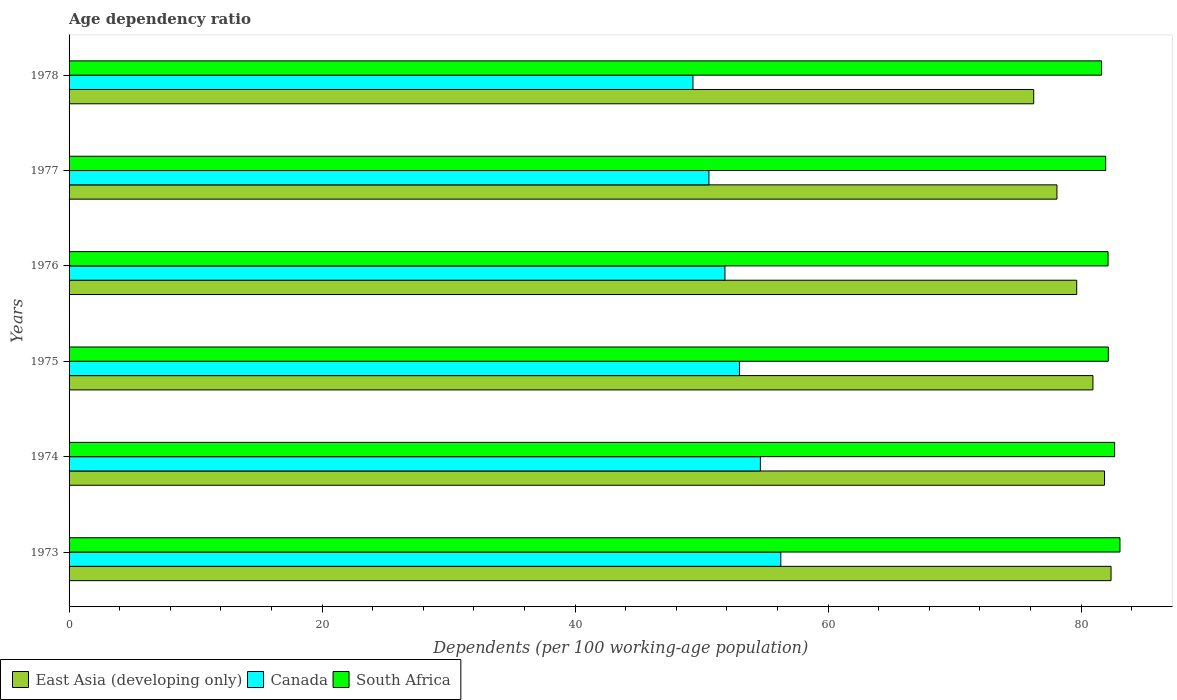How many different coloured bars are there?
Give a very brief answer. 3. Are the number of bars per tick equal to the number of legend labels?
Provide a short and direct response. Yes. Are the number of bars on each tick of the Y-axis equal?
Your answer should be compact. Yes. How many bars are there on the 2nd tick from the bottom?
Offer a terse response. 3. What is the label of the 2nd group of bars from the top?
Keep it short and to the point. 1977. In how many cases, is the number of bars for a given year not equal to the number of legend labels?
Your answer should be very brief. 0. What is the age dependency ratio in in East Asia (developing only) in 1974?
Your answer should be compact. 81.86. Across all years, what is the maximum age dependency ratio in in South Africa?
Provide a succinct answer. 83.08. Across all years, what is the minimum age dependency ratio in in East Asia (developing only)?
Ensure brevity in your answer.  76.26. In which year was the age dependency ratio in in South Africa maximum?
Your answer should be very brief. 1973. In which year was the age dependency ratio in in East Asia (developing only) minimum?
Your answer should be compact. 1978. What is the total age dependency ratio in in South Africa in the graph?
Ensure brevity in your answer.  493.59. What is the difference between the age dependency ratio in in South Africa in 1974 and that in 1975?
Your answer should be compact. 0.5. What is the difference between the age dependency ratio in in Canada in 1977 and the age dependency ratio in in East Asia (developing only) in 1975?
Your answer should be very brief. -30.36. What is the average age dependency ratio in in Canada per year?
Offer a terse response. 52.61. In the year 1978, what is the difference between the age dependency ratio in in South Africa and age dependency ratio in in East Asia (developing only)?
Give a very brief answer. 5.36. In how many years, is the age dependency ratio in in East Asia (developing only) greater than 12 %?
Provide a succinct answer. 6. What is the ratio of the age dependency ratio in in East Asia (developing only) in 1973 to that in 1978?
Provide a succinct answer. 1.08. Is the difference between the age dependency ratio in in South Africa in 1973 and 1974 greater than the difference between the age dependency ratio in in East Asia (developing only) in 1973 and 1974?
Keep it short and to the point. No. What is the difference between the highest and the second highest age dependency ratio in in Canada?
Keep it short and to the point. 1.62. What is the difference between the highest and the lowest age dependency ratio in in South Africa?
Make the answer very short. 1.46. What does the 3rd bar from the bottom in 1976 represents?
Provide a short and direct response. South Africa. How many years are there in the graph?
Your answer should be very brief. 6. How are the legend labels stacked?
Provide a succinct answer. Horizontal. What is the title of the graph?
Provide a succinct answer. Age dependency ratio. What is the label or title of the X-axis?
Make the answer very short. Dependents (per 100 working-age population). What is the label or title of the Y-axis?
Offer a terse response. Years. What is the Dependents (per 100 working-age population) of East Asia (developing only) in 1973?
Your response must be concise. 82.37. What is the Dependents (per 100 working-age population) in Canada in 1973?
Your response must be concise. 56.27. What is the Dependents (per 100 working-age population) of South Africa in 1973?
Your answer should be compact. 83.08. What is the Dependents (per 100 working-age population) in East Asia (developing only) in 1974?
Your answer should be compact. 81.86. What is the Dependents (per 100 working-age population) in Canada in 1974?
Ensure brevity in your answer.  54.65. What is the Dependents (per 100 working-age population) of South Africa in 1974?
Offer a terse response. 82.66. What is the Dependents (per 100 working-age population) in East Asia (developing only) in 1975?
Your answer should be very brief. 80.94. What is the Dependents (per 100 working-age population) of Canada in 1975?
Make the answer very short. 53. What is the Dependents (per 100 working-age population) in South Africa in 1975?
Make the answer very short. 82.15. What is the Dependents (per 100 working-age population) of East Asia (developing only) in 1976?
Make the answer very short. 79.66. What is the Dependents (per 100 working-age population) in Canada in 1976?
Make the answer very short. 51.85. What is the Dependents (per 100 working-age population) of South Africa in 1976?
Give a very brief answer. 82.14. What is the Dependents (per 100 working-age population) in East Asia (developing only) in 1977?
Your response must be concise. 78.1. What is the Dependents (per 100 working-age population) of Canada in 1977?
Your answer should be very brief. 50.58. What is the Dependents (per 100 working-age population) of South Africa in 1977?
Make the answer very short. 81.95. What is the Dependents (per 100 working-age population) of East Asia (developing only) in 1978?
Your answer should be very brief. 76.26. What is the Dependents (per 100 working-age population) of Canada in 1978?
Your answer should be compact. 49.32. What is the Dependents (per 100 working-age population) of South Africa in 1978?
Offer a terse response. 81.62. Across all years, what is the maximum Dependents (per 100 working-age population) in East Asia (developing only)?
Your response must be concise. 82.37. Across all years, what is the maximum Dependents (per 100 working-age population) of Canada?
Provide a short and direct response. 56.27. Across all years, what is the maximum Dependents (per 100 working-age population) of South Africa?
Make the answer very short. 83.08. Across all years, what is the minimum Dependents (per 100 working-age population) in East Asia (developing only)?
Ensure brevity in your answer.  76.26. Across all years, what is the minimum Dependents (per 100 working-age population) in Canada?
Provide a succinct answer. 49.32. Across all years, what is the minimum Dependents (per 100 working-age population) of South Africa?
Provide a short and direct response. 81.62. What is the total Dependents (per 100 working-age population) in East Asia (developing only) in the graph?
Give a very brief answer. 479.18. What is the total Dependents (per 100 working-age population) of Canada in the graph?
Make the answer very short. 315.67. What is the total Dependents (per 100 working-age population) in South Africa in the graph?
Your answer should be very brief. 493.59. What is the difference between the Dependents (per 100 working-age population) of East Asia (developing only) in 1973 and that in 1974?
Keep it short and to the point. 0.52. What is the difference between the Dependents (per 100 working-age population) in Canada in 1973 and that in 1974?
Your answer should be compact. 1.62. What is the difference between the Dependents (per 100 working-age population) of South Africa in 1973 and that in 1974?
Offer a very short reply. 0.42. What is the difference between the Dependents (per 100 working-age population) of East Asia (developing only) in 1973 and that in 1975?
Provide a short and direct response. 1.43. What is the difference between the Dependents (per 100 working-age population) of Canada in 1973 and that in 1975?
Make the answer very short. 3.27. What is the difference between the Dependents (per 100 working-age population) in South Africa in 1973 and that in 1975?
Provide a succinct answer. 0.92. What is the difference between the Dependents (per 100 working-age population) of East Asia (developing only) in 1973 and that in 1976?
Make the answer very short. 2.71. What is the difference between the Dependents (per 100 working-age population) in Canada in 1973 and that in 1976?
Ensure brevity in your answer.  4.41. What is the difference between the Dependents (per 100 working-age population) in South Africa in 1973 and that in 1976?
Give a very brief answer. 0.94. What is the difference between the Dependents (per 100 working-age population) in East Asia (developing only) in 1973 and that in 1977?
Offer a very short reply. 4.28. What is the difference between the Dependents (per 100 working-age population) in Canada in 1973 and that in 1977?
Offer a terse response. 5.68. What is the difference between the Dependents (per 100 working-age population) in South Africa in 1973 and that in 1977?
Your response must be concise. 1.13. What is the difference between the Dependents (per 100 working-age population) of East Asia (developing only) in 1973 and that in 1978?
Your answer should be compact. 6.11. What is the difference between the Dependents (per 100 working-age population) in Canada in 1973 and that in 1978?
Your response must be concise. 6.94. What is the difference between the Dependents (per 100 working-age population) in South Africa in 1973 and that in 1978?
Your answer should be very brief. 1.46. What is the difference between the Dependents (per 100 working-age population) of East Asia (developing only) in 1974 and that in 1975?
Offer a very short reply. 0.92. What is the difference between the Dependents (per 100 working-age population) in Canada in 1974 and that in 1975?
Offer a terse response. 1.65. What is the difference between the Dependents (per 100 working-age population) in South Africa in 1974 and that in 1975?
Offer a very short reply. 0.5. What is the difference between the Dependents (per 100 working-age population) in East Asia (developing only) in 1974 and that in 1976?
Give a very brief answer. 2.2. What is the difference between the Dependents (per 100 working-age population) of Canada in 1974 and that in 1976?
Ensure brevity in your answer.  2.8. What is the difference between the Dependents (per 100 working-age population) in South Africa in 1974 and that in 1976?
Offer a very short reply. 0.52. What is the difference between the Dependents (per 100 working-age population) of East Asia (developing only) in 1974 and that in 1977?
Keep it short and to the point. 3.76. What is the difference between the Dependents (per 100 working-age population) in Canada in 1974 and that in 1977?
Your response must be concise. 4.07. What is the difference between the Dependents (per 100 working-age population) of South Africa in 1974 and that in 1977?
Your answer should be very brief. 0.71. What is the difference between the Dependents (per 100 working-age population) of East Asia (developing only) in 1974 and that in 1978?
Provide a short and direct response. 5.6. What is the difference between the Dependents (per 100 working-age population) of Canada in 1974 and that in 1978?
Provide a short and direct response. 5.33. What is the difference between the Dependents (per 100 working-age population) of South Africa in 1974 and that in 1978?
Offer a terse response. 1.03. What is the difference between the Dependents (per 100 working-age population) in East Asia (developing only) in 1975 and that in 1976?
Give a very brief answer. 1.28. What is the difference between the Dependents (per 100 working-age population) of Canada in 1975 and that in 1976?
Keep it short and to the point. 1.15. What is the difference between the Dependents (per 100 working-age population) in South Africa in 1975 and that in 1976?
Offer a terse response. 0.02. What is the difference between the Dependents (per 100 working-age population) in East Asia (developing only) in 1975 and that in 1977?
Give a very brief answer. 2.84. What is the difference between the Dependents (per 100 working-age population) of Canada in 1975 and that in 1977?
Ensure brevity in your answer.  2.41. What is the difference between the Dependents (per 100 working-age population) in South Africa in 1975 and that in 1977?
Offer a very short reply. 0.21. What is the difference between the Dependents (per 100 working-age population) of East Asia (developing only) in 1975 and that in 1978?
Your answer should be very brief. 4.68. What is the difference between the Dependents (per 100 working-age population) of Canada in 1975 and that in 1978?
Your answer should be compact. 3.67. What is the difference between the Dependents (per 100 working-age population) in South Africa in 1975 and that in 1978?
Provide a short and direct response. 0.53. What is the difference between the Dependents (per 100 working-age population) of East Asia (developing only) in 1976 and that in 1977?
Make the answer very short. 1.56. What is the difference between the Dependents (per 100 working-age population) of Canada in 1976 and that in 1977?
Provide a succinct answer. 1.27. What is the difference between the Dependents (per 100 working-age population) in South Africa in 1976 and that in 1977?
Ensure brevity in your answer.  0.19. What is the difference between the Dependents (per 100 working-age population) of East Asia (developing only) in 1976 and that in 1978?
Your answer should be very brief. 3.4. What is the difference between the Dependents (per 100 working-age population) of Canada in 1976 and that in 1978?
Give a very brief answer. 2.53. What is the difference between the Dependents (per 100 working-age population) of South Africa in 1976 and that in 1978?
Provide a succinct answer. 0.52. What is the difference between the Dependents (per 100 working-age population) in East Asia (developing only) in 1977 and that in 1978?
Provide a short and direct response. 1.84. What is the difference between the Dependents (per 100 working-age population) in Canada in 1977 and that in 1978?
Make the answer very short. 1.26. What is the difference between the Dependents (per 100 working-age population) in South Africa in 1977 and that in 1978?
Provide a short and direct response. 0.33. What is the difference between the Dependents (per 100 working-age population) of East Asia (developing only) in 1973 and the Dependents (per 100 working-age population) of Canada in 1974?
Keep it short and to the point. 27.72. What is the difference between the Dependents (per 100 working-age population) in East Asia (developing only) in 1973 and the Dependents (per 100 working-age population) in South Africa in 1974?
Keep it short and to the point. -0.28. What is the difference between the Dependents (per 100 working-age population) of Canada in 1973 and the Dependents (per 100 working-age population) of South Africa in 1974?
Your answer should be compact. -26.39. What is the difference between the Dependents (per 100 working-age population) of East Asia (developing only) in 1973 and the Dependents (per 100 working-age population) of Canada in 1975?
Your answer should be compact. 29.38. What is the difference between the Dependents (per 100 working-age population) in East Asia (developing only) in 1973 and the Dependents (per 100 working-age population) in South Africa in 1975?
Offer a very short reply. 0.22. What is the difference between the Dependents (per 100 working-age population) in Canada in 1973 and the Dependents (per 100 working-age population) in South Africa in 1975?
Your answer should be very brief. -25.89. What is the difference between the Dependents (per 100 working-age population) of East Asia (developing only) in 1973 and the Dependents (per 100 working-age population) of Canada in 1976?
Offer a very short reply. 30.52. What is the difference between the Dependents (per 100 working-age population) of East Asia (developing only) in 1973 and the Dependents (per 100 working-age population) of South Africa in 1976?
Provide a succinct answer. 0.23. What is the difference between the Dependents (per 100 working-age population) of Canada in 1973 and the Dependents (per 100 working-age population) of South Africa in 1976?
Make the answer very short. -25.87. What is the difference between the Dependents (per 100 working-age population) in East Asia (developing only) in 1973 and the Dependents (per 100 working-age population) in Canada in 1977?
Your answer should be very brief. 31.79. What is the difference between the Dependents (per 100 working-age population) of East Asia (developing only) in 1973 and the Dependents (per 100 working-age population) of South Africa in 1977?
Your response must be concise. 0.42. What is the difference between the Dependents (per 100 working-age population) in Canada in 1973 and the Dependents (per 100 working-age population) in South Africa in 1977?
Keep it short and to the point. -25.68. What is the difference between the Dependents (per 100 working-age population) in East Asia (developing only) in 1973 and the Dependents (per 100 working-age population) in Canada in 1978?
Your response must be concise. 33.05. What is the difference between the Dependents (per 100 working-age population) of East Asia (developing only) in 1973 and the Dependents (per 100 working-age population) of South Africa in 1978?
Your answer should be compact. 0.75. What is the difference between the Dependents (per 100 working-age population) of Canada in 1973 and the Dependents (per 100 working-age population) of South Africa in 1978?
Offer a very short reply. -25.36. What is the difference between the Dependents (per 100 working-age population) in East Asia (developing only) in 1974 and the Dependents (per 100 working-age population) in Canada in 1975?
Ensure brevity in your answer.  28.86. What is the difference between the Dependents (per 100 working-age population) of East Asia (developing only) in 1974 and the Dependents (per 100 working-age population) of South Africa in 1975?
Offer a terse response. -0.3. What is the difference between the Dependents (per 100 working-age population) in Canada in 1974 and the Dependents (per 100 working-age population) in South Africa in 1975?
Give a very brief answer. -27.5. What is the difference between the Dependents (per 100 working-age population) in East Asia (developing only) in 1974 and the Dependents (per 100 working-age population) in Canada in 1976?
Ensure brevity in your answer.  30.01. What is the difference between the Dependents (per 100 working-age population) of East Asia (developing only) in 1974 and the Dependents (per 100 working-age population) of South Africa in 1976?
Your answer should be compact. -0.28. What is the difference between the Dependents (per 100 working-age population) of Canada in 1974 and the Dependents (per 100 working-age population) of South Africa in 1976?
Your response must be concise. -27.49. What is the difference between the Dependents (per 100 working-age population) in East Asia (developing only) in 1974 and the Dependents (per 100 working-age population) in Canada in 1977?
Keep it short and to the point. 31.27. What is the difference between the Dependents (per 100 working-age population) in East Asia (developing only) in 1974 and the Dependents (per 100 working-age population) in South Africa in 1977?
Offer a terse response. -0.09. What is the difference between the Dependents (per 100 working-age population) in Canada in 1974 and the Dependents (per 100 working-age population) in South Africa in 1977?
Offer a terse response. -27.3. What is the difference between the Dependents (per 100 working-age population) in East Asia (developing only) in 1974 and the Dependents (per 100 working-age population) in Canada in 1978?
Keep it short and to the point. 32.53. What is the difference between the Dependents (per 100 working-age population) of East Asia (developing only) in 1974 and the Dependents (per 100 working-age population) of South Africa in 1978?
Provide a short and direct response. 0.24. What is the difference between the Dependents (per 100 working-age population) in Canada in 1974 and the Dependents (per 100 working-age population) in South Africa in 1978?
Provide a succinct answer. -26.97. What is the difference between the Dependents (per 100 working-age population) in East Asia (developing only) in 1975 and the Dependents (per 100 working-age population) in Canada in 1976?
Ensure brevity in your answer.  29.09. What is the difference between the Dependents (per 100 working-age population) of East Asia (developing only) in 1975 and the Dependents (per 100 working-age population) of South Africa in 1976?
Provide a succinct answer. -1.2. What is the difference between the Dependents (per 100 working-age population) of Canada in 1975 and the Dependents (per 100 working-age population) of South Africa in 1976?
Your response must be concise. -29.14. What is the difference between the Dependents (per 100 working-age population) of East Asia (developing only) in 1975 and the Dependents (per 100 working-age population) of Canada in 1977?
Offer a very short reply. 30.36. What is the difference between the Dependents (per 100 working-age population) of East Asia (developing only) in 1975 and the Dependents (per 100 working-age population) of South Africa in 1977?
Keep it short and to the point. -1.01. What is the difference between the Dependents (per 100 working-age population) of Canada in 1975 and the Dependents (per 100 working-age population) of South Africa in 1977?
Give a very brief answer. -28.95. What is the difference between the Dependents (per 100 working-age population) of East Asia (developing only) in 1975 and the Dependents (per 100 working-age population) of Canada in 1978?
Ensure brevity in your answer.  31.62. What is the difference between the Dependents (per 100 working-age population) of East Asia (developing only) in 1975 and the Dependents (per 100 working-age population) of South Africa in 1978?
Your response must be concise. -0.68. What is the difference between the Dependents (per 100 working-age population) in Canada in 1975 and the Dependents (per 100 working-age population) in South Africa in 1978?
Keep it short and to the point. -28.62. What is the difference between the Dependents (per 100 working-age population) of East Asia (developing only) in 1976 and the Dependents (per 100 working-age population) of Canada in 1977?
Your answer should be very brief. 29.08. What is the difference between the Dependents (per 100 working-age population) in East Asia (developing only) in 1976 and the Dependents (per 100 working-age population) in South Africa in 1977?
Your response must be concise. -2.29. What is the difference between the Dependents (per 100 working-age population) in Canada in 1976 and the Dependents (per 100 working-age population) in South Africa in 1977?
Ensure brevity in your answer.  -30.1. What is the difference between the Dependents (per 100 working-age population) of East Asia (developing only) in 1976 and the Dependents (per 100 working-age population) of Canada in 1978?
Provide a short and direct response. 30.34. What is the difference between the Dependents (per 100 working-age population) in East Asia (developing only) in 1976 and the Dependents (per 100 working-age population) in South Africa in 1978?
Provide a succinct answer. -1.96. What is the difference between the Dependents (per 100 working-age population) of Canada in 1976 and the Dependents (per 100 working-age population) of South Africa in 1978?
Your response must be concise. -29.77. What is the difference between the Dependents (per 100 working-age population) in East Asia (developing only) in 1977 and the Dependents (per 100 working-age population) in Canada in 1978?
Offer a very short reply. 28.77. What is the difference between the Dependents (per 100 working-age population) in East Asia (developing only) in 1977 and the Dependents (per 100 working-age population) in South Africa in 1978?
Make the answer very short. -3.52. What is the difference between the Dependents (per 100 working-age population) of Canada in 1977 and the Dependents (per 100 working-age population) of South Africa in 1978?
Your answer should be compact. -31.04. What is the average Dependents (per 100 working-age population) of East Asia (developing only) per year?
Provide a succinct answer. 79.86. What is the average Dependents (per 100 working-age population) in Canada per year?
Provide a succinct answer. 52.61. What is the average Dependents (per 100 working-age population) in South Africa per year?
Your answer should be very brief. 82.27. In the year 1973, what is the difference between the Dependents (per 100 working-age population) of East Asia (developing only) and Dependents (per 100 working-age population) of Canada?
Your answer should be very brief. 26.11. In the year 1973, what is the difference between the Dependents (per 100 working-age population) in East Asia (developing only) and Dependents (per 100 working-age population) in South Africa?
Provide a short and direct response. -0.7. In the year 1973, what is the difference between the Dependents (per 100 working-age population) in Canada and Dependents (per 100 working-age population) in South Africa?
Ensure brevity in your answer.  -26.81. In the year 1974, what is the difference between the Dependents (per 100 working-age population) in East Asia (developing only) and Dependents (per 100 working-age population) in Canada?
Your response must be concise. 27.21. In the year 1974, what is the difference between the Dependents (per 100 working-age population) in East Asia (developing only) and Dependents (per 100 working-age population) in South Africa?
Give a very brief answer. -0.8. In the year 1974, what is the difference between the Dependents (per 100 working-age population) of Canada and Dependents (per 100 working-age population) of South Africa?
Your answer should be compact. -28.01. In the year 1975, what is the difference between the Dependents (per 100 working-age population) in East Asia (developing only) and Dependents (per 100 working-age population) in Canada?
Keep it short and to the point. 27.94. In the year 1975, what is the difference between the Dependents (per 100 working-age population) of East Asia (developing only) and Dependents (per 100 working-age population) of South Africa?
Give a very brief answer. -1.21. In the year 1975, what is the difference between the Dependents (per 100 working-age population) of Canada and Dependents (per 100 working-age population) of South Africa?
Give a very brief answer. -29.16. In the year 1976, what is the difference between the Dependents (per 100 working-age population) of East Asia (developing only) and Dependents (per 100 working-age population) of Canada?
Ensure brevity in your answer.  27.81. In the year 1976, what is the difference between the Dependents (per 100 working-age population) of East Asia (developing only) and Dependents (per 100 working-age population) of South Africa?
Your answer should be compact. -2.48. In the year 1976, what is the difference between the Dependents (per 100 working-age population) in Canada and Dependents (per 100 working-age population) in South Africa?
Your answer should be compact. -30.29. In the year 1977, what is the difference between the Dependents (per 100 working-age population) in East Asia (developing only) and Dependents (per 100 working-age population) in Canada?
Ensure brevity in your answer.  27.51. In the year 1977, what is the difference between the Dependents (per 100 working-age population) of East Asia (developing only) and Dependents (per 100 working-age population) of South Africa?
Your response must be concise. -3.85. In the year 1977, what is the difference between the Dependents (per 100 working-age population) in Canada and Dependents (per 100 working-age population) in South Africa?
Your answer should be compact. -31.36. In the year 1978, what is the difference between the Dependents (per 100 working-age population) in East Asia (developing only) and Dependents (per 100 working-age population) in Canada?
Ensure brevity in your answer.  26.94. In the year 1978, what is the difference between the Dependents (per 100 working-age population) of East Asia (developing only) and Dependents (per 100 working-age population) of South Africa?
Provide a short and direct response. -5.36. In the year 1978, what is the difference between the Dependents (per 100 working-age population) in Canada and Dependents (per 100 working-age population) in South Africa?
Keep it short and to the point. -32.3. What is the ratio of the Dependents (per 100 working-age population) in East Asia (developing only) in 1973 to that in 1974?
Provide a short and direct response. 1.01. What is the ratio of the Dependents (per 100 working-age population) of Canada in 1973 to that in 1974?
Offer a very short reply. 1.03. What is the ratio of the Dependents (per 100 working-age population) of South Africa in 1973 to that in 1974?
Your answer should be very brief. 1.01. What is the ratio of the Dependents (per 100 working-age population) in East Asia (developing only) in 1973 to that in 1975?
Provide a succinct answer. 1.02. What is the ratio of the Dependents (per 100 working-age population) of Canada in 1973 to that in 1975?
Provide a short and direct response. 1.06. What is the ratio of the Dependents (per 100 working-age population) of South Africa in 1973 to that in 1975?
Your answer should be compact. 1.01. What is the ratio of the Dependents (per 100 working-age population) of East Asia (developing only) in 1973 to that in 1976?
Your response must be concise. 1.03. What is the ratio of the Dependents (per 100 working-age population) in Canada in 1973 to that in 1976?
Provide a short and direct response. 1.09. What is the ratio of the Dependents (per 100 working-age population) in South Africa in 1973 to that in 1976?
Ensure brevity in your answer.  1.01. What is the ratio of the Dependents (per 100 working-age population) in East Asia (developing only) in 1973 to that in 1977?
Give a very brief answer. 1.05. What is the ratio of the Dependents (per 100 working-age population) in Canada in 1973 to that in 1977?
Ensure brevity in your answer.  1.11. What is the ratio of the Dependents (per 100 working-age population) in South Africa in 1973 to that in 1977?
Your answer should be very brief. 1.01. What is the ratio of the Dependents (per 100 working-age population) of East Asia (developing only) in 1973 to that in 1978?
Keep it short and to the point. 1.08. What is the ratio of the Dependents (per 100 working-age population) in Canada in 1973 to that in 1978?
Provide a succinct answer. 1.14. What is the ratio of the Dependents (per 100 working-age population) in South Africa in 1973 to that in 1978?
Keep it short and to the point. 1.02. What is the ratio of the Dependents (per 100 working-age population) of East Asia (developing only) in 1974 to that in 1975?
Keep it short and to the point. 1.01. What is the ratio of the Dependents (per 100 working-age population) of Canada in 1974 to that in 1975?
Provide a succinct answer. 1.03. What is the ratio of the Dependents (per 100 working-age population) in South Africa in 1974 to that in 1975?
Offer a terse response. 1.01. What is the ratio of the Dependents (per 100 working-age population) in East Asia (developing only) in 1974 to that in 1976?
Provide a succinct answer. 1.03. What is the ratio of the Dependents (per 100 working-age population) of Canada in 1974 to that in 1976?
Provide a short and direct response. 1.05. What is the ratio of the Dependents (per 100 working-age population) in South Africa in 1974 to that in 1976?
Offer a very short reply. 1.01. What is the ratio of the Dependents (per 100 working-age population) of East Asia (developing only) in 1974 to that in 1977?
Ensure brevity in your answer.  1.05. What is the ratio of the Dependents (per 100 working-age population) in Canada in 1974 to that in 1977?
Keep it short and to the point. 1.08. What is the ratio of the Dependents (per 100 working-age population) of South Africa in 1974 to that in 1977?
Provide a short and direct response. 1.01. What is the ratio of the Dependents (per 100 working-age population) in East Asia (developing only) in 1974 to that in 1978?
Your answer should be very brief. 1.07. What is the ratio of the Dependents (per 100 working-age population) in Canada in 1974 to that in 1978?
Your answer should be very brief. 1.11. What is the ratio of the Dependents (per 100 working-age population) in South Africa in 1974 to that in 1978?
Ensure brevity in your answer.  1.01. What is the ratio of the Dependents (per 100 working-age population) of East Asia (developing only) in 1975 to that in 1976?
Provide a succinct answer. 1.02. What is the ratio of the Dependents (per 100 working-age population) of Canada in 1975 to that in 1976?
Provide a short and direct response. 1.02. What is the ratio of the Dependents (per 100 working-age population) in East Asia (developing only) in 1975 to that in 1977?
Your response must be concise. 1.04. What is the ratio of the Dependents (per 100 working-age population) in Canada in 1975 to that in 1977?
Offer a very short reply. 1.05. What is the ratio of the Dependents (per 100 working-age population) of East Asia (developing only) in 1975 to that in 1978?
Keep it short and to the point. 1.06. What is the ratio of the Dependents (per 100 working-age population) in Canada in 1975 to that in 1978?
Offer a terse response. 1.07. What is the ratio of the Dependents (per 100 working-age population) in South Africa in 1975 to that in 1978?
Your answer should be very brief. 1.01. What is the ratio of the Dependents (per 100 working-age population) in South Africa in 1976 to that in 1977?
Ensure brevity in your answer.  1. What is the ratio of the Dependents (per 100 working-age population) in East Asia (developing only) in 1976 to that in 1978?
Provide a succinct answer. 1.04. What is the ratio of the Dependents (per 100 working-age population) in Canada in 1976 to that in 1978?
Ensure brevity in your answer.  1.05. What is the ratio of the Dependents (per 100 working-age population) in South Africa in 1976 to that in 1978?
Make the answer very short. 1.01. What is the ratio of the Dependents (per 100 working-age population) of East Asia (developing only) in 1977 to that in 1978?
Provide a short and direct response. 1.02. What is the ratio of the Dependents (per 100 working-age population) of Canada in 1977 to that in 1978?
Give a very brief answer. 1.03. What is the difference between the highest and the second highest Dependents (per 100 working-age population) of East Asia (developing only)?
Keep it short and to the point. 0.52. What is the difference between the highest and the second highest Dependents (per 100 working-age population) of Canada?
Make the answer very short. 1.62. What is the difference between the highest and the second highest Dependents (per 100 working-age population) in South Africa?
Make the answer very short. 0.42. What is the difference between the highest and the lowest Dependents (per 100 working-age population) in East Asia (developing only)?
Ensure brevity in your answer.  6.11. What is the difference between the highest and the lowest Dependents (per 100 working-age population) in Canada?
Provide a succinct answer. 6.94. What is the difference between the highest and the lowest Dependents (per 100 working-age population) of South Africa?
Offer a terse response. 1.46. 